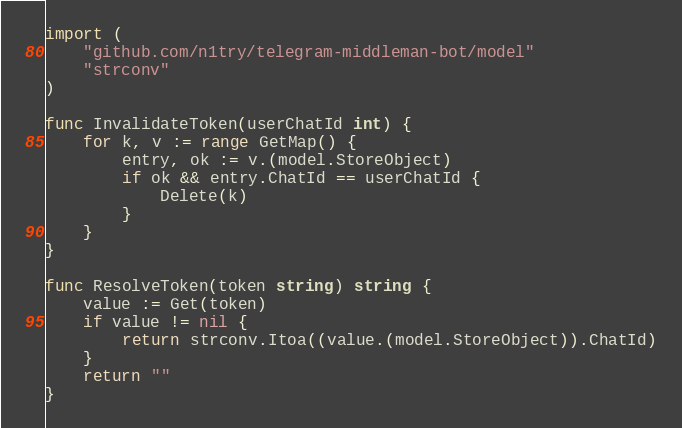<code> <loc_0><loc_0><loc_500><loc_500><_Go_>import (
	"github.com/n1try/telegram-middleman-bot/model"
	"strconv"
)

func InvalidateToken(userChatId int) {
	for k, v := range GetMap() {
		entry, ok := v.(model.StoreObject)
		if ok && entry.ChatId == userChatId {
			Delete(k)
		}
	}
}

func ResolveToken(token string) string {
	value := Get(token)
	if value != nil {
		return strconv.Itoa((value.(model.StoreObject)).ChatId)
	}
	return ""
}
</code> 